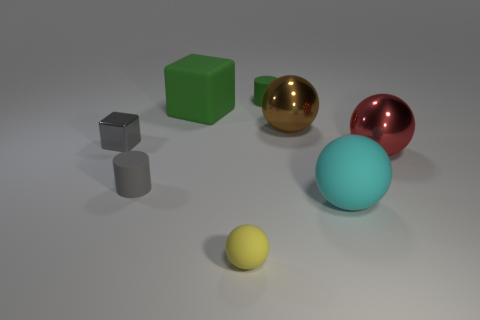Add 1 tiny purple metal balls. How many objects exist? 9 Subtract all cylinders. How many objects are left? 6 Add 3 cyan spheres. How many cyan spheres are left? 4 Add 3 big red spheres. How many big red spheres exist? 4 Subtract 1 green cylinders. How many objects are left? 7 Subtract all small purple rubber things. Subtract all rubber things. How many objects are left? 3 